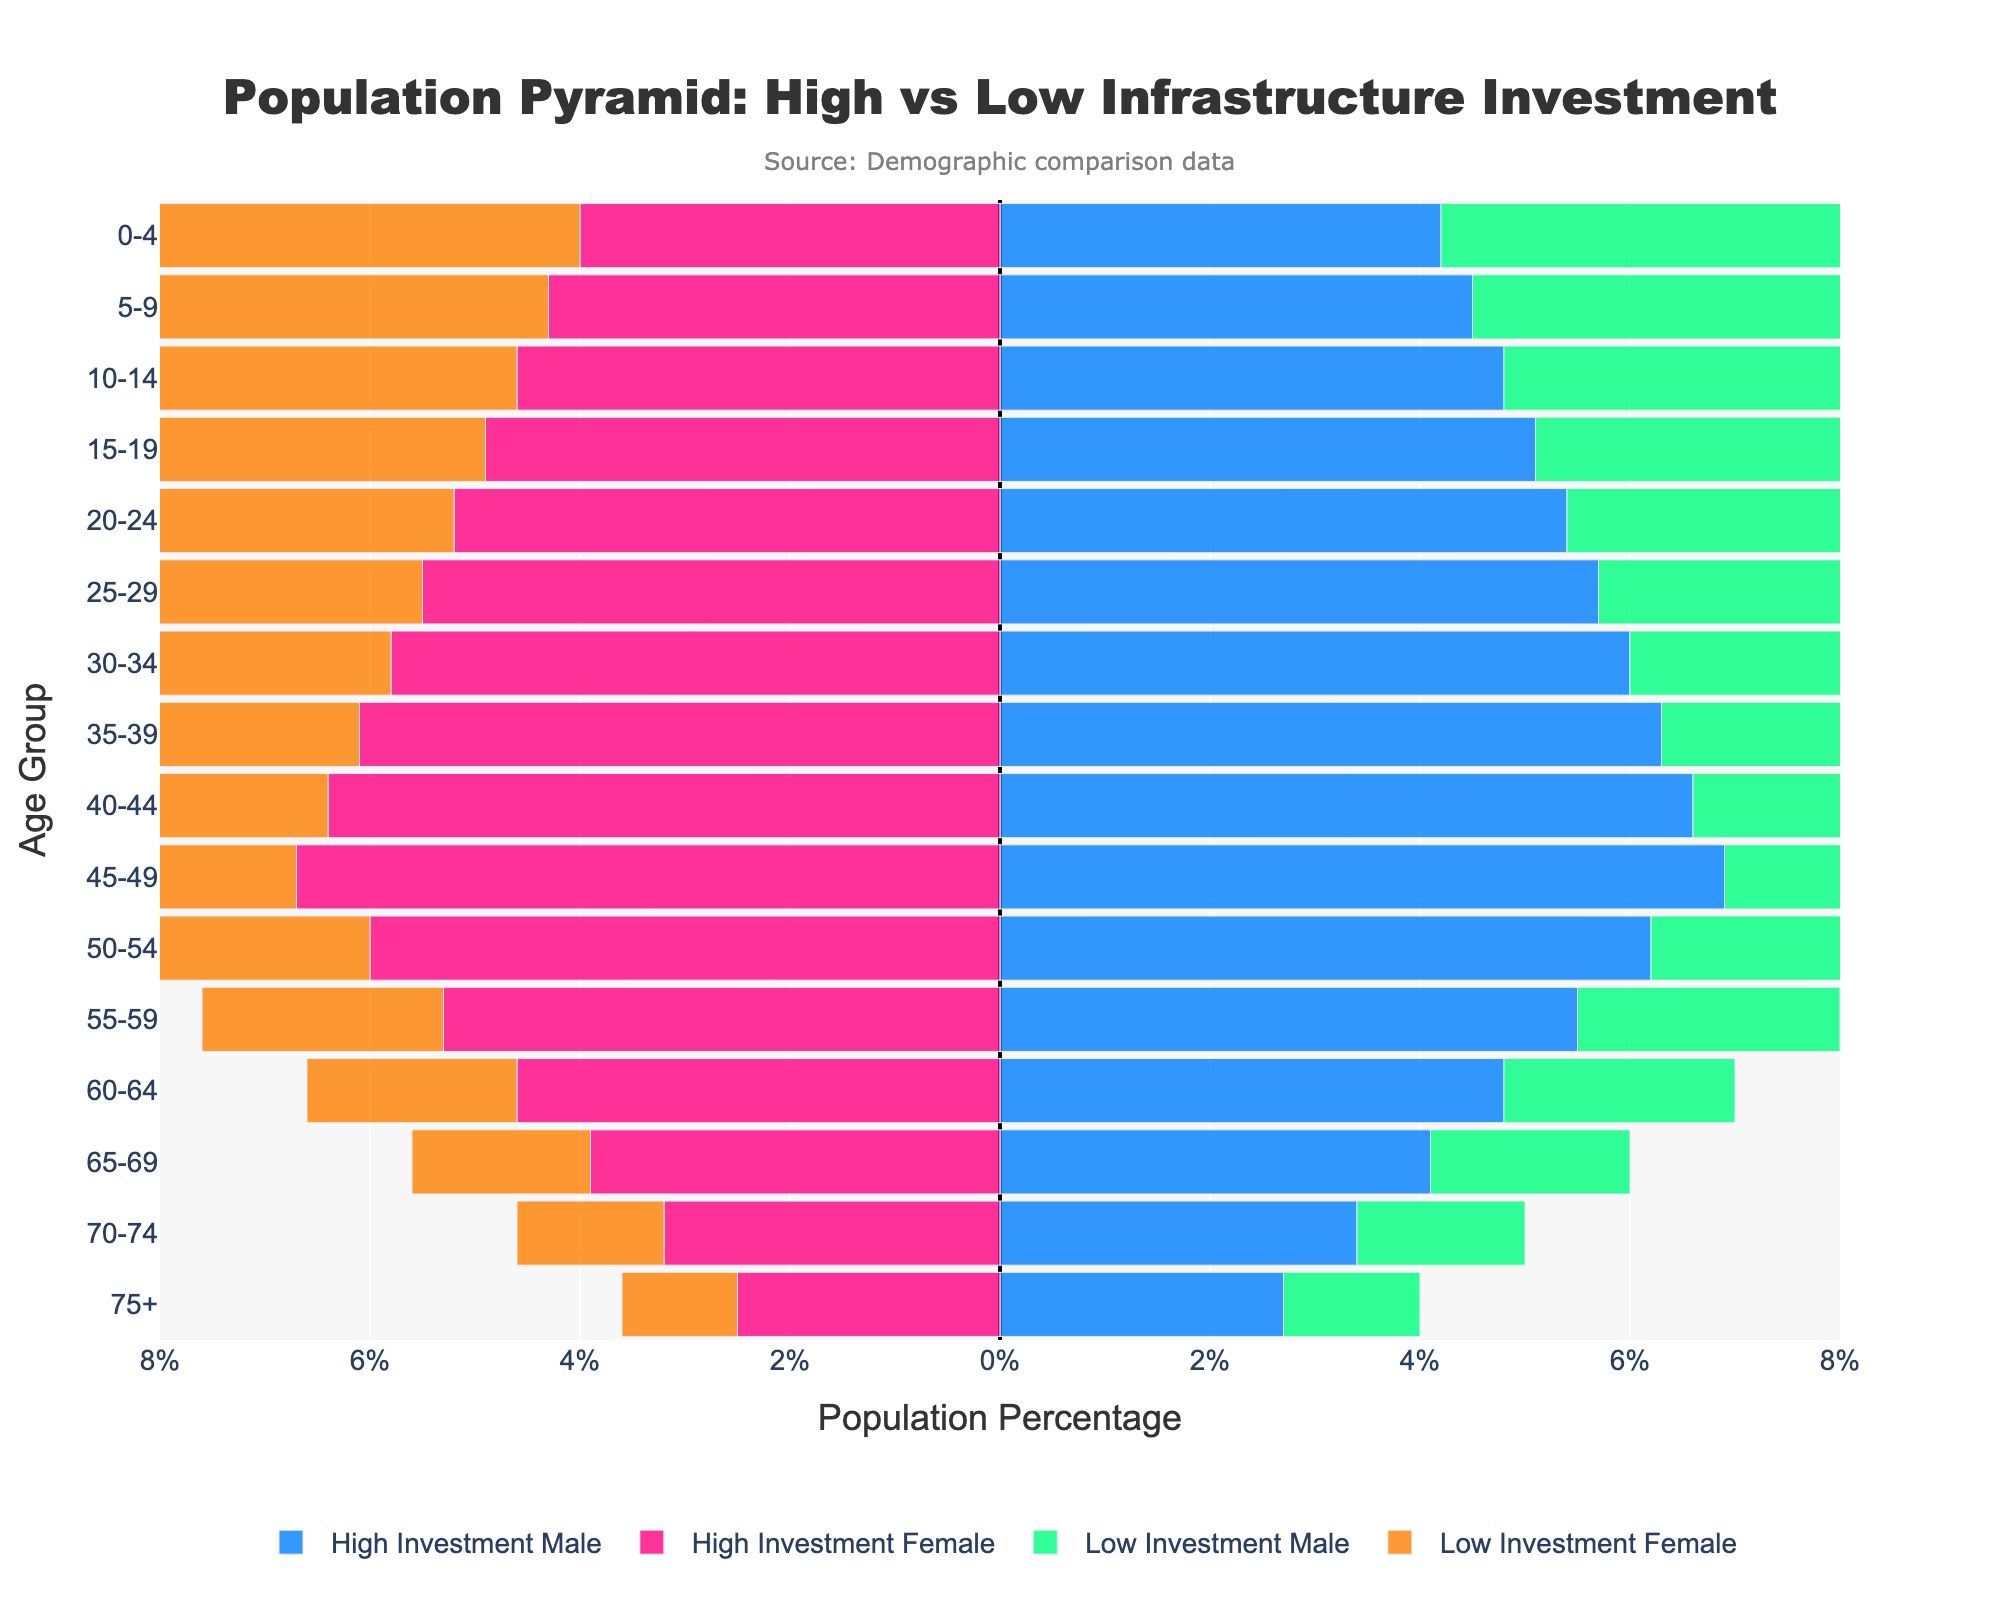What is the title of the figure? The title of the figure is located at the top and typically summarizes the theme or main point of the chart.
Answer: Population Pyramid: High vs Low Infrastructure Investment What are the colors representing male and female populations in high investment countries? By looking at the color coding in the legend, we see that males in high investment countries are represented in blue and females are represented in pink.
Answer: Blue (males) and Pink (females) In which age group do high investment countries have the highest percentage of males? By examining the bars representing males from high investment countries, we see that the highest bar corresponds to the 45-49 age group.
Answer: 45-49 How does the population percentage of females aged 65-69 compare between high and low investment countries? By comparing the lengths of the bars for females aged 65-69, we see that high investment countries have higher percentage values.
Answer: Higher in high investment countries What is the visible trend in the population distribution for high investment countries? Observing the decreasing pattern of the bars from younger to older age groups, we see a trend of a larger youth population and a smaller elderly population in high investment countries.
Answer: Larger youth population Which gender and investment category has the lowest representation in the 75+ age group? By looking at the smallest bars, low investment females in the 75+ age group have the lowest representation.
Answer: Low investment females How does the male population percentage in high investment countries for the 0-4 age group compare to the 45-49 age group? By comparing the heights of the bars, the 0-4 age group is one of the smallest while 45-49 is the largest, indicating fewer males in the youngest age group than the mid-aged group for high investment countries.
Answer: Lower in 0-4 What is one key difference in the population distribution trends between high and low investment countries? Observing the overall shapes of both pyramids, high investment countries have a broader base, indicating a younger population, whereas low investment countries have a more consistent taper, indicating a relatively even distribution or an aging population.
Answer: Younger population in high investment What could be a potential implication of the population structure in high investment countries on their economic growth? A higher percentage of the youth population, as seen in high investment countries, may indicate a growing future workforce which could support sustained economic growth.
Answer: Potential for sustained growth due to a future workforce 